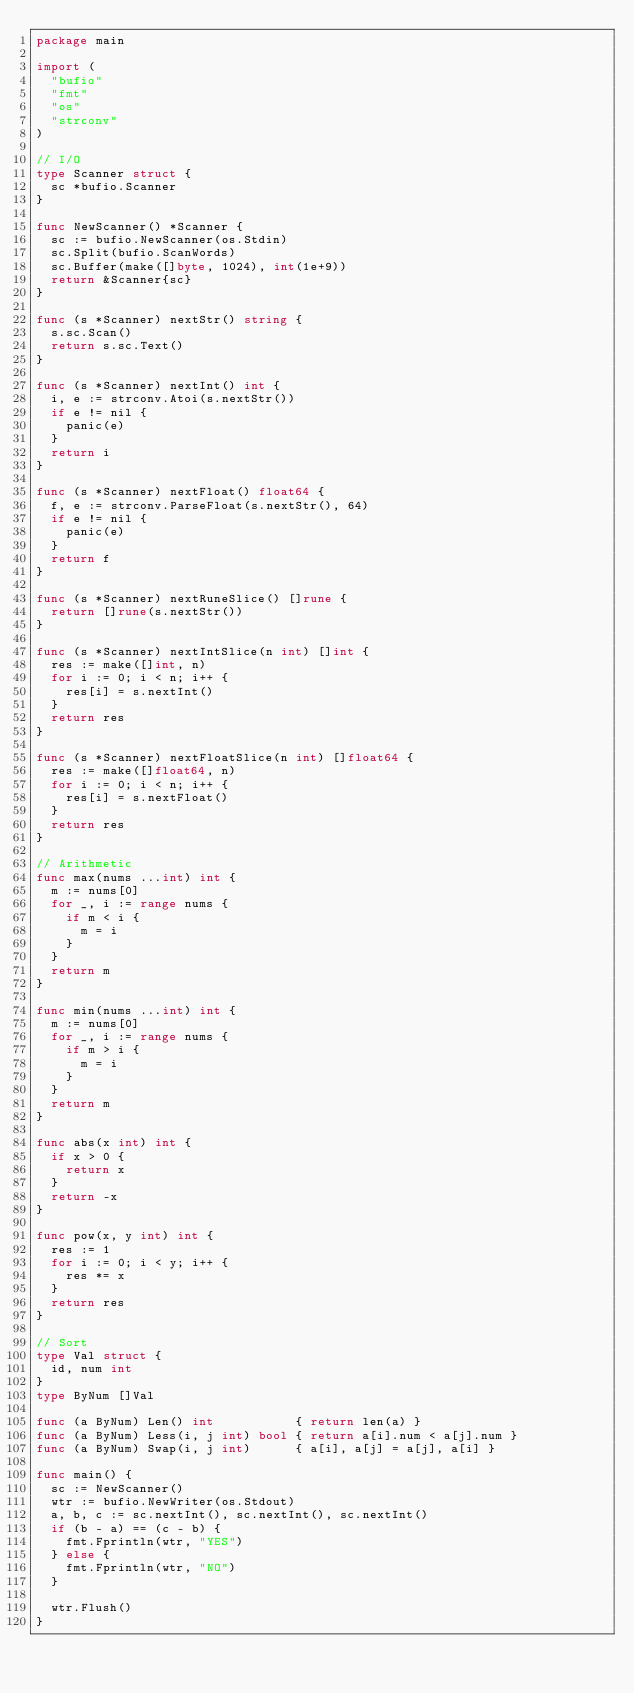Convert code to text. <code><loc_0><loc_0><loc_500><loc_500><_Go_>package main

import (
	"bufio"
	"fmt"
	"os"
	"strconv"
)

// I/O
type Scanner struct {
	sc *bufio.Scanner
}

func NewScanner() *Scanner {
	sc := bufio.NewScanner(os.Stdin)
	sc.Split(bufio.ScanWords)
	sc.Buffer(make([]byte, 1024), int(1e+9))
	return &Scanner{sc}
}

func (s *Scanner) nextStr() string {
	s.sc.Scan()
	return s.sc.Text()
}

func (s *Scanner) nextInt() int {
	i, e := strconv.Atoi(s.nextStr())
	if e != nil {
		panic(e)
	}
	return i
}

func (s *Scanner) nextFloat() float64 {
	f, e := strconv.ParseFloat(s.nextStr(), 64)
	if e != nil {
		panic(e)
	}
	return f
}

func (s *Scanner) nextRuneSlice() []rune {
	return []rune(s.nextStr())
}

func (s *Scanner) nextIntSlice(n int) []int {
	res := make([]int, n)
	for i := 0; i < n; i++ {
		res[i] = s.nextInt()
	}
	return res
}

func (s *Scanner) nextFloatSlice(n int) []float64 {
	res := make([]float64, n)
	for i := 0; i < n; i++ {
		res[i] = s.nextFloat()
	}
	return res
}

// Arithmetic
func max(nums ...int) int {
	m := nums[0]
	for _, i := range nums {
		if m < i {
			m = i
		}
	}
	return m
}

func min(nums ...int) int {
	m := nums[0]
	for _, i := range nums {
		if m > i {
			m = i
		}
	}
	return m
}

func abs(x int) int {
	if x > 0 {
		return x
	}
	return -x
}

func pow(x, y int) int {
	res := 1
	for i := 0; i < y; i++ {
		res *= x
	}
	return res
}

// Sort
type Val struct {
	id, num int
}
type ByNum []Val

func (a ByNum) Len() int           { return len(a) }
func (a ByNum) Less(i, j int) bool { return a[i].num < a[j].num }
func (a ByNum) Swap(i, j int)      { a[i], a[j] = a[j], a[i] }

func main() {
	sc := NewScanner()
	wtr := bufio.NewWriter(os.Stdout)
	a, b, c := sc.nextInt(), sc.nextInt(), sc.nextInt()
	if (b - a) == (c - b) {
		fmt.Fprintln(wtr, "YES")
	} else {
		fmt.Fprintln(wtr, "NO")
	}

	wtr.Flush()
}
</code> 